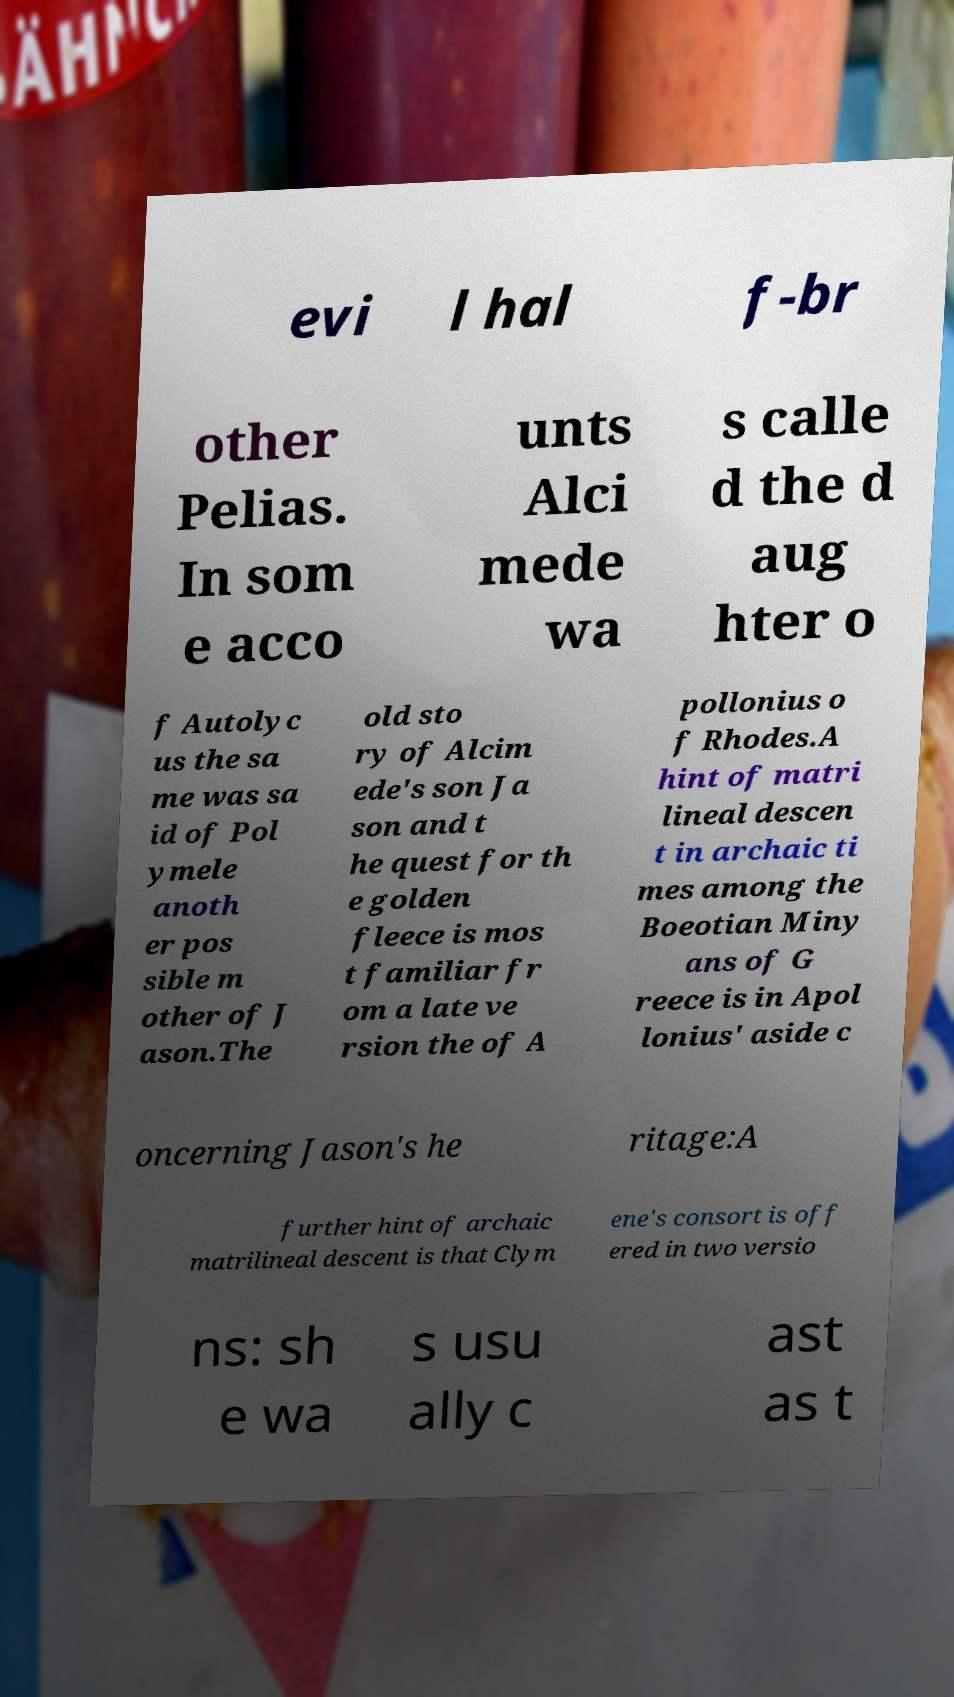Can you read and provide the text displayed in the image?This photo seems to have some interesting text. Can you extract and type it out for me? evi l hal f-br other Pelias. In som e acco unts Alci mede wa s calle d the d aug hter o f Autolyc us the sa me was sa id of Pol ymele anoth er pos sible m other of J ason.The old sto ry of Alcim ede's son Ja son and t he quest for th e golden fleece is mos t familiar fr om a late ve rsion the of A pollonius o f Rhodes.A hint of matri lineal descen t in archaic ti mes among the Boeotian Miny ans of G reece is in Apol lonius' aside c oncerning Jason's he ritage:A further hint of archaic matrilineal descent is that Clym ene's consort is off ered in two versio ns: sh e wa s usu ally c ast as t 